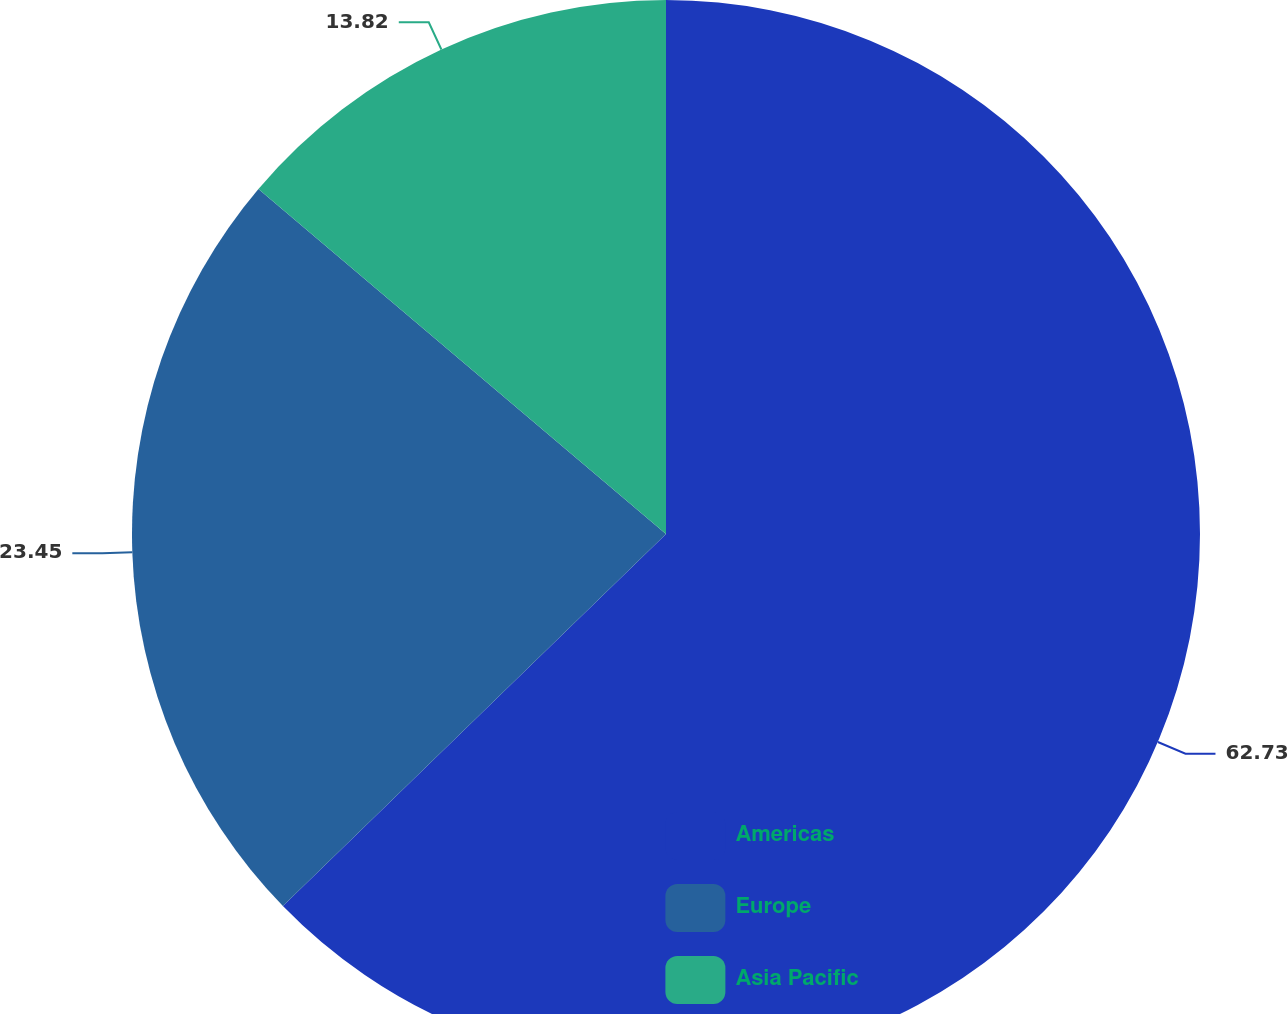<chart> <loc_0><loc_0><loc_500><loc_500><pie_chart><fcel>Americas<fcel>Europe<fcel>Asia Pacific<nl><fcel>62.74%<fcel>23.45%<fcel>13.82%<nl></chart> 